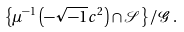<formula> <loc_0><loc_0><loc_500><loc_500>\left \{ \mu ^ { - 1 } \left ( - \sqrt { - 1 } c ^ { 2 } \right ) \cap \mathcal { S } \right \} / \mathcal { G } \, .</formula> 